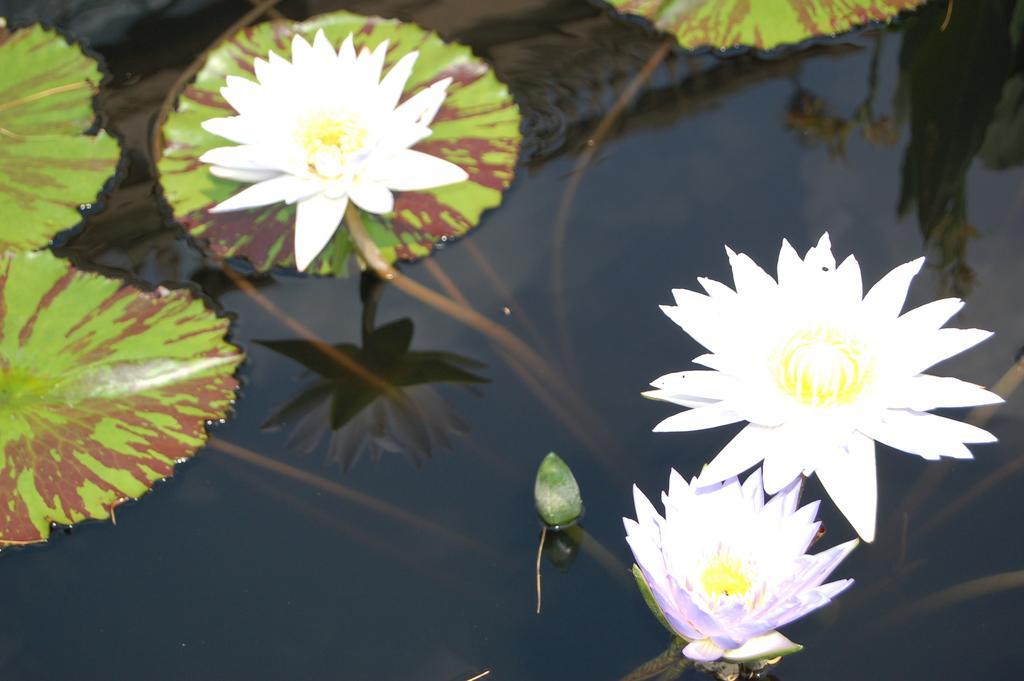Can you describe this image briefly? In this picture there are lotus flowers in the water pond with green leaves. 